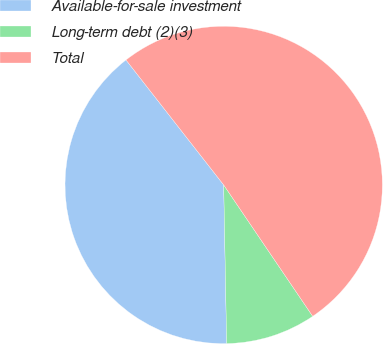<chart> <loc_0><loc_0><loc_500><loc_500><pie_chart><fcel>Available-for-sale investment<fcel>Long-term debt (2)(3)<fcel>Total<nl><fcel>39.74%<fcel>9.18%<fcel>51.08%<nl></chart> 